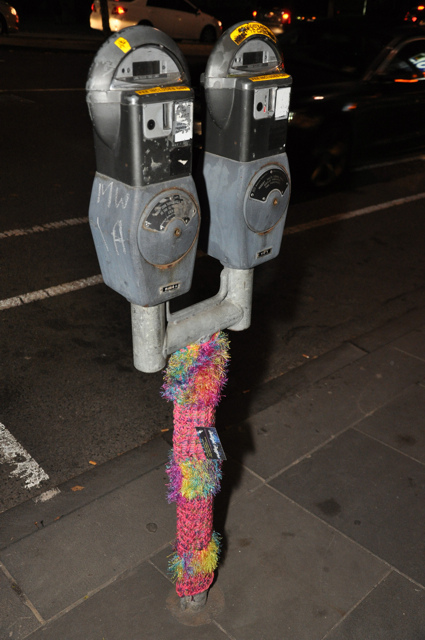Identify the text displayed in this image. MW A 